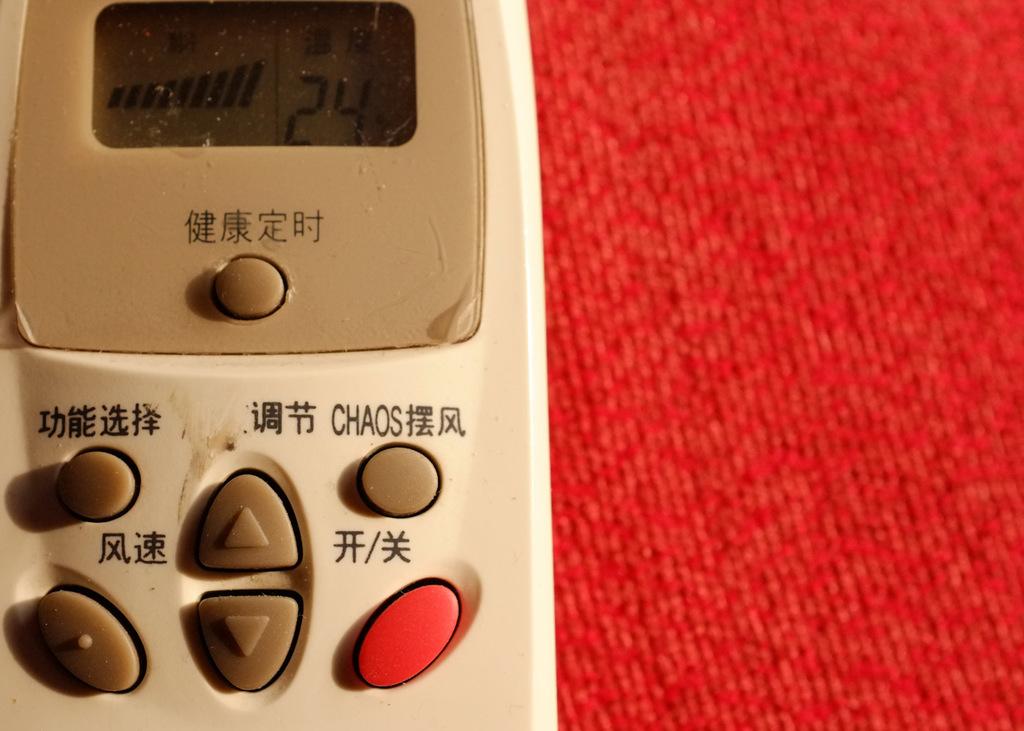What temperature reading is on the remote control?
Make the answer very short. 24. 